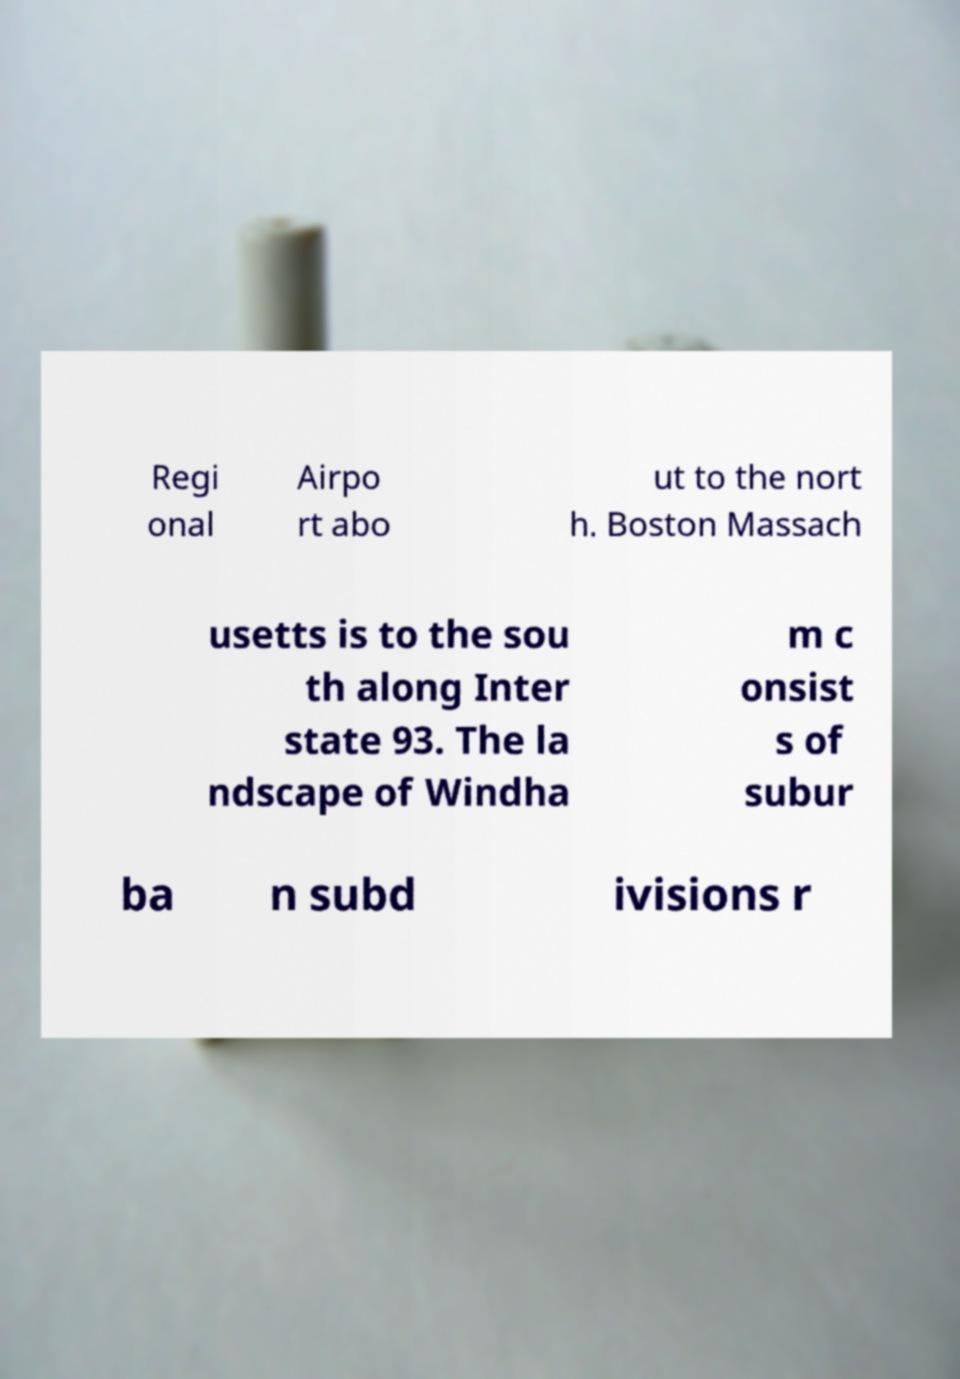Could you assist in decoding the text presented in this image and type it out clearly? Regi onal Airpo rt abo ut to the nort h. Boston Massach usetts is to the sou th along Inter state 93. The la ndscape of Windha m c onsist s of subur ba n subd ivisions r 